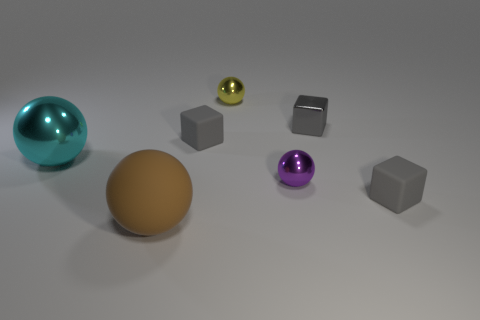What number of tiny green rubber blocks are there? 0 